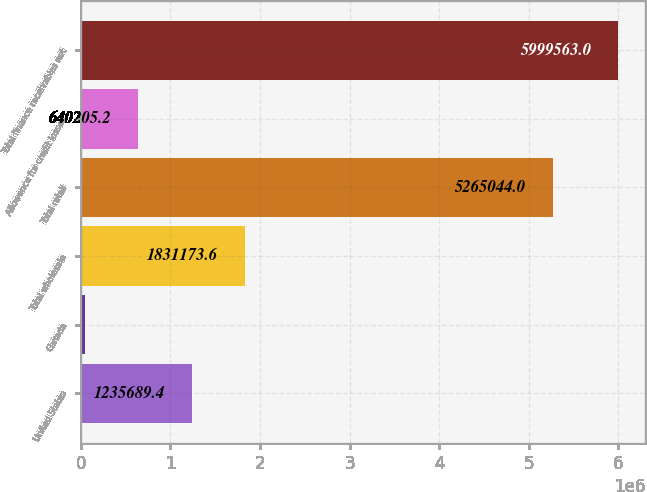<chart> <loc_0><loc_0><loc_500><loc_500><bar_chart><fcel>United States<fcel>Canada<fcel>Total wholesale<fcel>Total retail<fcel>Allowance for credit losses<fcel>Total finance receivables net<nl><fcel>1.23569e+06<fcel>44721<fcel>1.83117e+06<fcel>5.26504e+06<fcel>640205<fcel>5.99956e+06<nl></chart> 